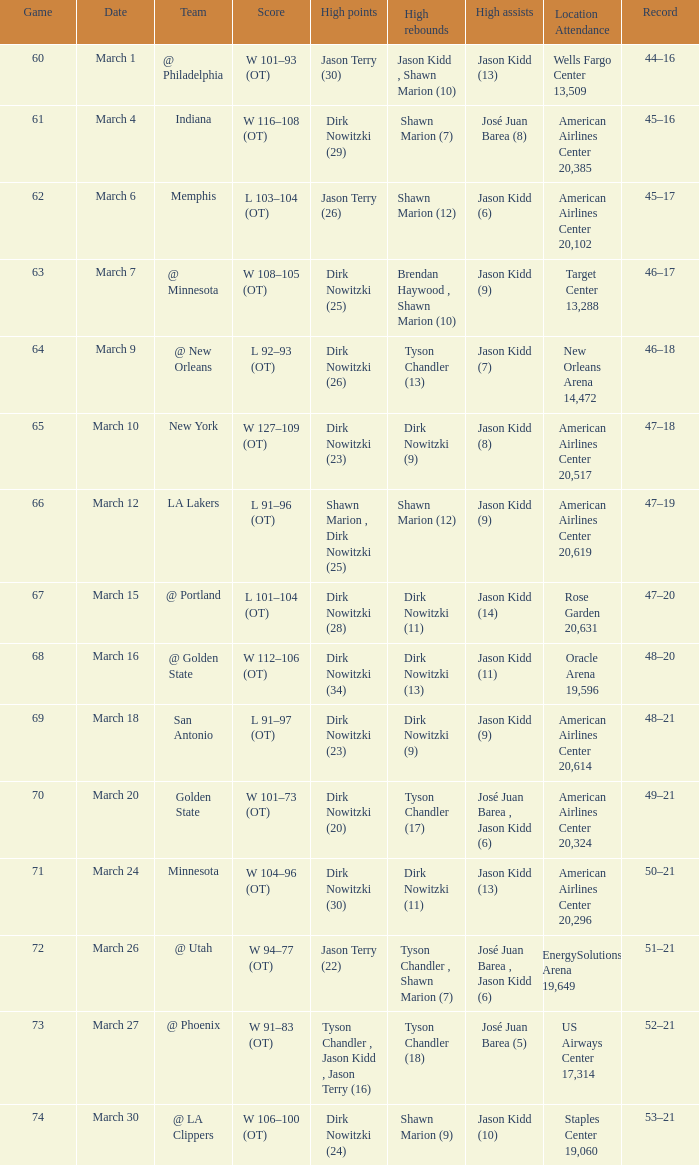Identify the top assists for l 103-104 (ot) Jason Kidd (6). 